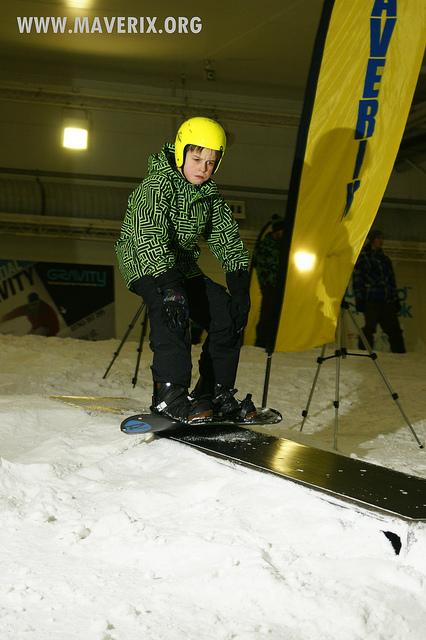Does the person look happy?
Write a very short answer. No. What is the person doing?
Keep it brief. Snowboarding. What color is his helmet?
Short answer required. Yellow. 